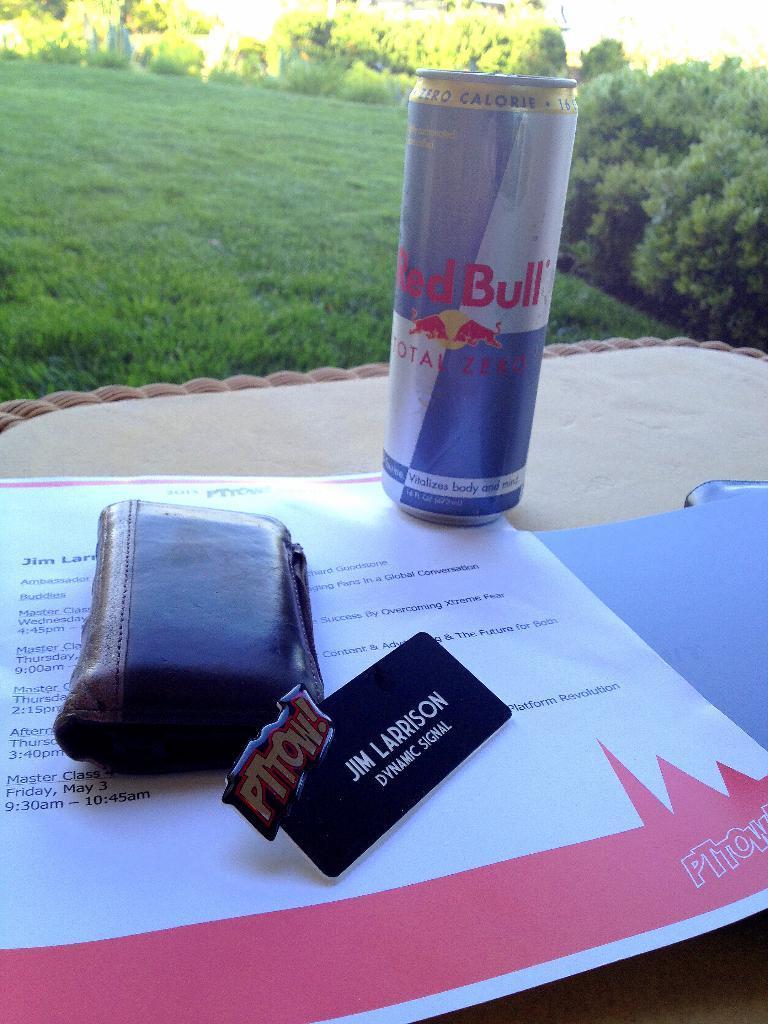Please provide a concise description of this image. In this image I can see a tin, a wallet, few papers on the cream color surface. Background I can see trees and grass in green color. 